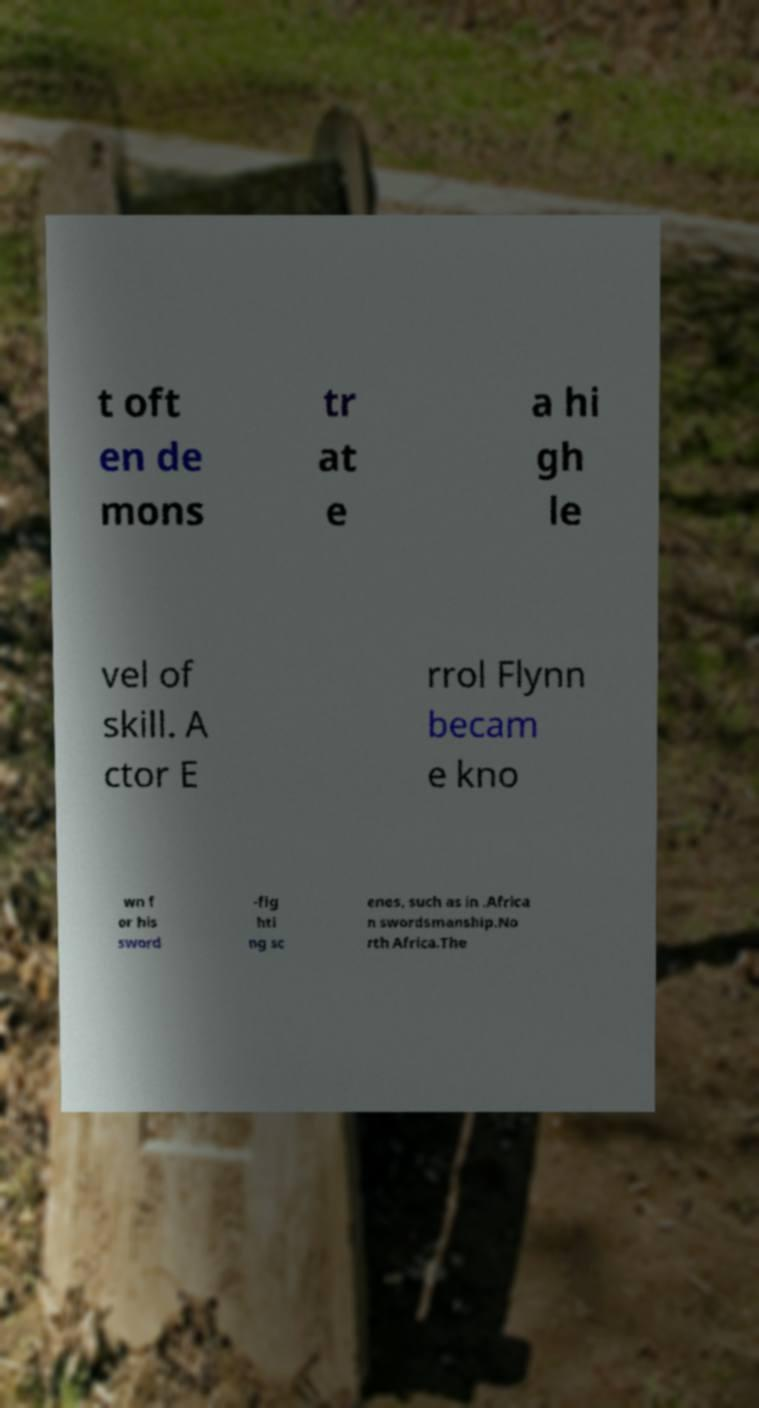I need the written content from this picture converted into text. Can you do that? t oft en de mons tr at e a hi gh le vel of skill. A ctor E rrol Flynn becam e kno wn f or his sword -fig hti ng sc enes, such as in .Africa n swordsmanship.No rth Africa.The 